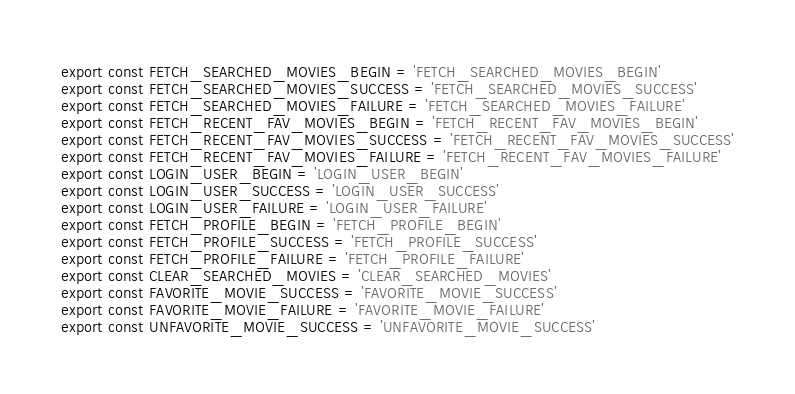<code> <loc_0><loc_0><loc_500><loc_500><_JavaScript_>export const FETCH_SEARCHED_MOVIES_BEGIN = 'FETCH_SEARCHED_MOVIES_BEGIN'
export const FETCH_SEARCHED_MOVIES_SUCCESS = 'FETCH_SEARCHED_MOVIES_SUCCESS'
export const FETCH_SEARCHED_MOVIES_FAILURE = 'FETCH_SEARCHED_MOVIES_FAILURE'
export const FETCH_RECENT_FAV_MOVIES_BEGIN = 'FETCH_RECENT_FAV_MOVIES_BEGIN'
export const FETCH_RECENT_FAV_MOVIES_SUCCESS = 'FETCH_RECENT_FAV_MOVIES_SUCCESS'
export const FETCH_RECENT_FAV_MOVIES_FAILURE = 'FETCH_RECENT_FAV_MOVIES_FAILURE'
export const LOGIN_USER_BEGIN = 'LOGIN_USER_BEGIN'
export const LOGIN_USER_SUCCESS = 'LOGIN_USER_SUCCESS'
export const LOGIN_USER_FAILURE = 'LOGIN_USER_FAILURE'
export const FETCH_PROFILE_BEGIN = 'FETCH_PROFILE_BEGIN'
export const FETCH_PROFILE_SUCCESS = 'FETCH_PROFILE_SUCCESS'
export const FETCH_PROFILE_FAILURE = 'FETCH_PROFILE_FAILURE'
export const CLEAR_SEARCHED_MOVIES = 'CLEAR_SEARCHED_MOVIES'
export const FAVORITE_MOVIE_SUCCESS = 'FAVORITE_MOVIE_SUCCESS'
export const FAVORITE_MOVIE_FAILURE = 'FAVORITE_MOVIE_FAILURE'
export const UNFAVORITE_MOVIE_SUCCESS = 'UNFAVORITE_MOVIE_SUCCESS'</code> 